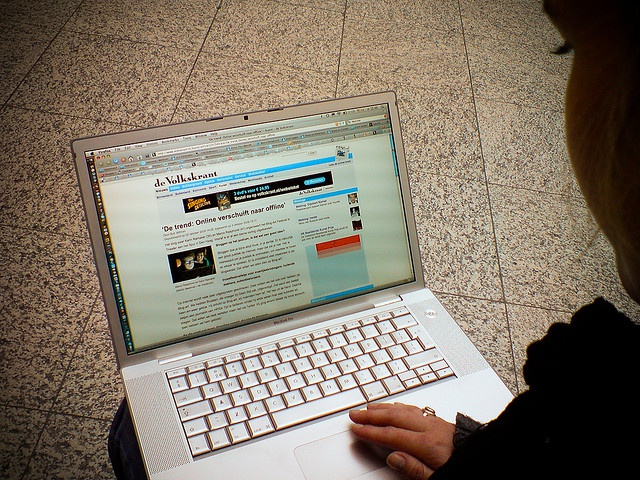Describe the objects in this image and their specific colors. I can see laptop in black, lightgray, darkgray, and gray tones and people in black, maroon, and brown tones in this image. 